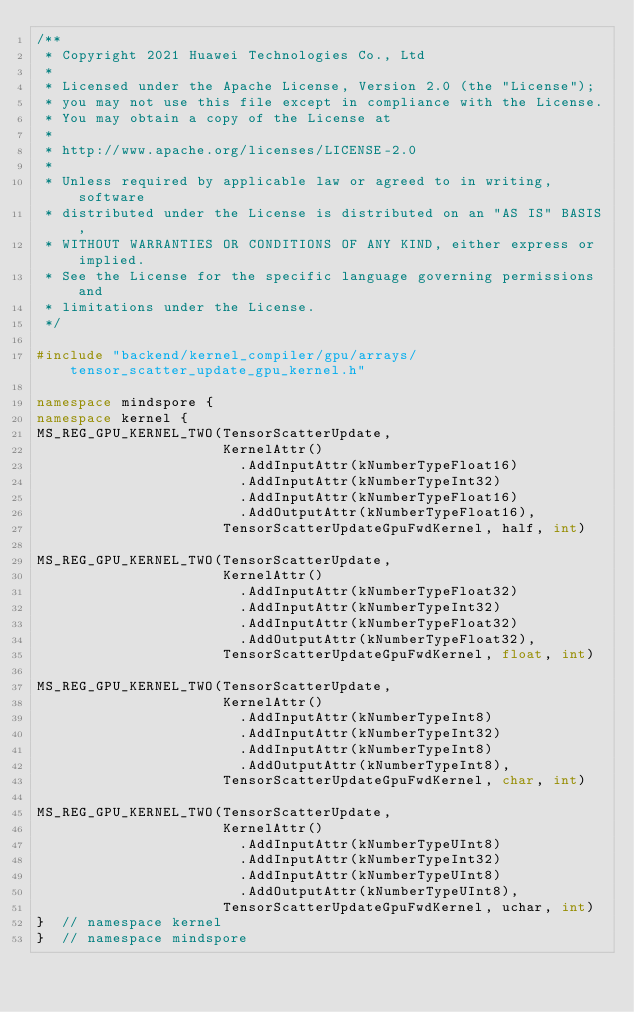Convert code to text. <code><loc_0><loc_0><loc_500><loc_500><_C++_>/**
 * Copyright 2021 Huawei Technologies Co., Ltd
 *
 * Licensed under the Apache License, Version 2.0 (the "License");
 * you may not use this file except in compliance with the License.
 * You may obtain a copy of the License at
 *
 * http://www.apache.org/licenses/LICENSE-2.0
 *
 * Unless required by applicable law or agreed to in writing, software
 * distributed under the License is distributed on an "AS IS" BASIS,
 * WITHOUT WARRANTIES OR CONDITIONS OF ANY KIND, either express or implied.
 * See the License for the specific language governing permissions and
 * limitations under the License.
 */

#include "backend/kernel_compiler/gpu/arrays/tensor_scatter_update_gpu_kernel.h"

namespace mindspore {
namespace kernel {
MS_REG_GPU_KERNEL_TWO(TensorScatterUpdate,
                      KernelAttr()
                        .AddInputAttr(kNumberTypeFloat16)
                        .AddInputAttr(kNumberTypeInt32)
                        .AddInputAttr(kNumberTypeFloat16)
                        .AddOutputAttr(kNumberTypeFloat16),
                      TensorScatterUpdateGpuFwdKernel, half, int)

MS_REG_GPU_KERNEL_TWO(TensorScatterUpdate,
                      KernelAttr()
                        .AddInputAttr(kNumberTypeFloat32)
                        .AddInputAttr(kNumberTypeInt32)
                        .AddInputAttr(kNumberTypeFloat32)
                        .AddOutputAttr(kNumberTypeFloat32),
                      TensorScatterUpdateGpuFwdKernel, float, int)

MS_REG_GPU_KERNEL_TWO(TensorScatterUpdate,
                      KernelAttr()
                        .AddInputAttr(kNumberTypeInt8)
                        .AddInputAttr(kNumberTypeInt32)
                        .AddInputAttr(kNumberTypeInt8)
                        .AddOutputAttr(kNumberTypeInt8),
                      TensorScatterUpdateGpuFwdKernel, char, int)

MS_REG_GPU_KERNEL_TWO(TensorScatterUpdate,
                      KernelAttr()
                        .AddInputAttr(kNumberTypeUInt8)
                        .AddInputAttr(kNumberTypeInt32)
                        .AddInputAttr(kNumberTypeUInt8)
                        .AddOutputAttr(kNumberTypeUInt8),
                      TensorScatterUpdateGpuFwdKernel, uchar, int)
}  // namespace kernel
}  // namespace mindspore
</code> 